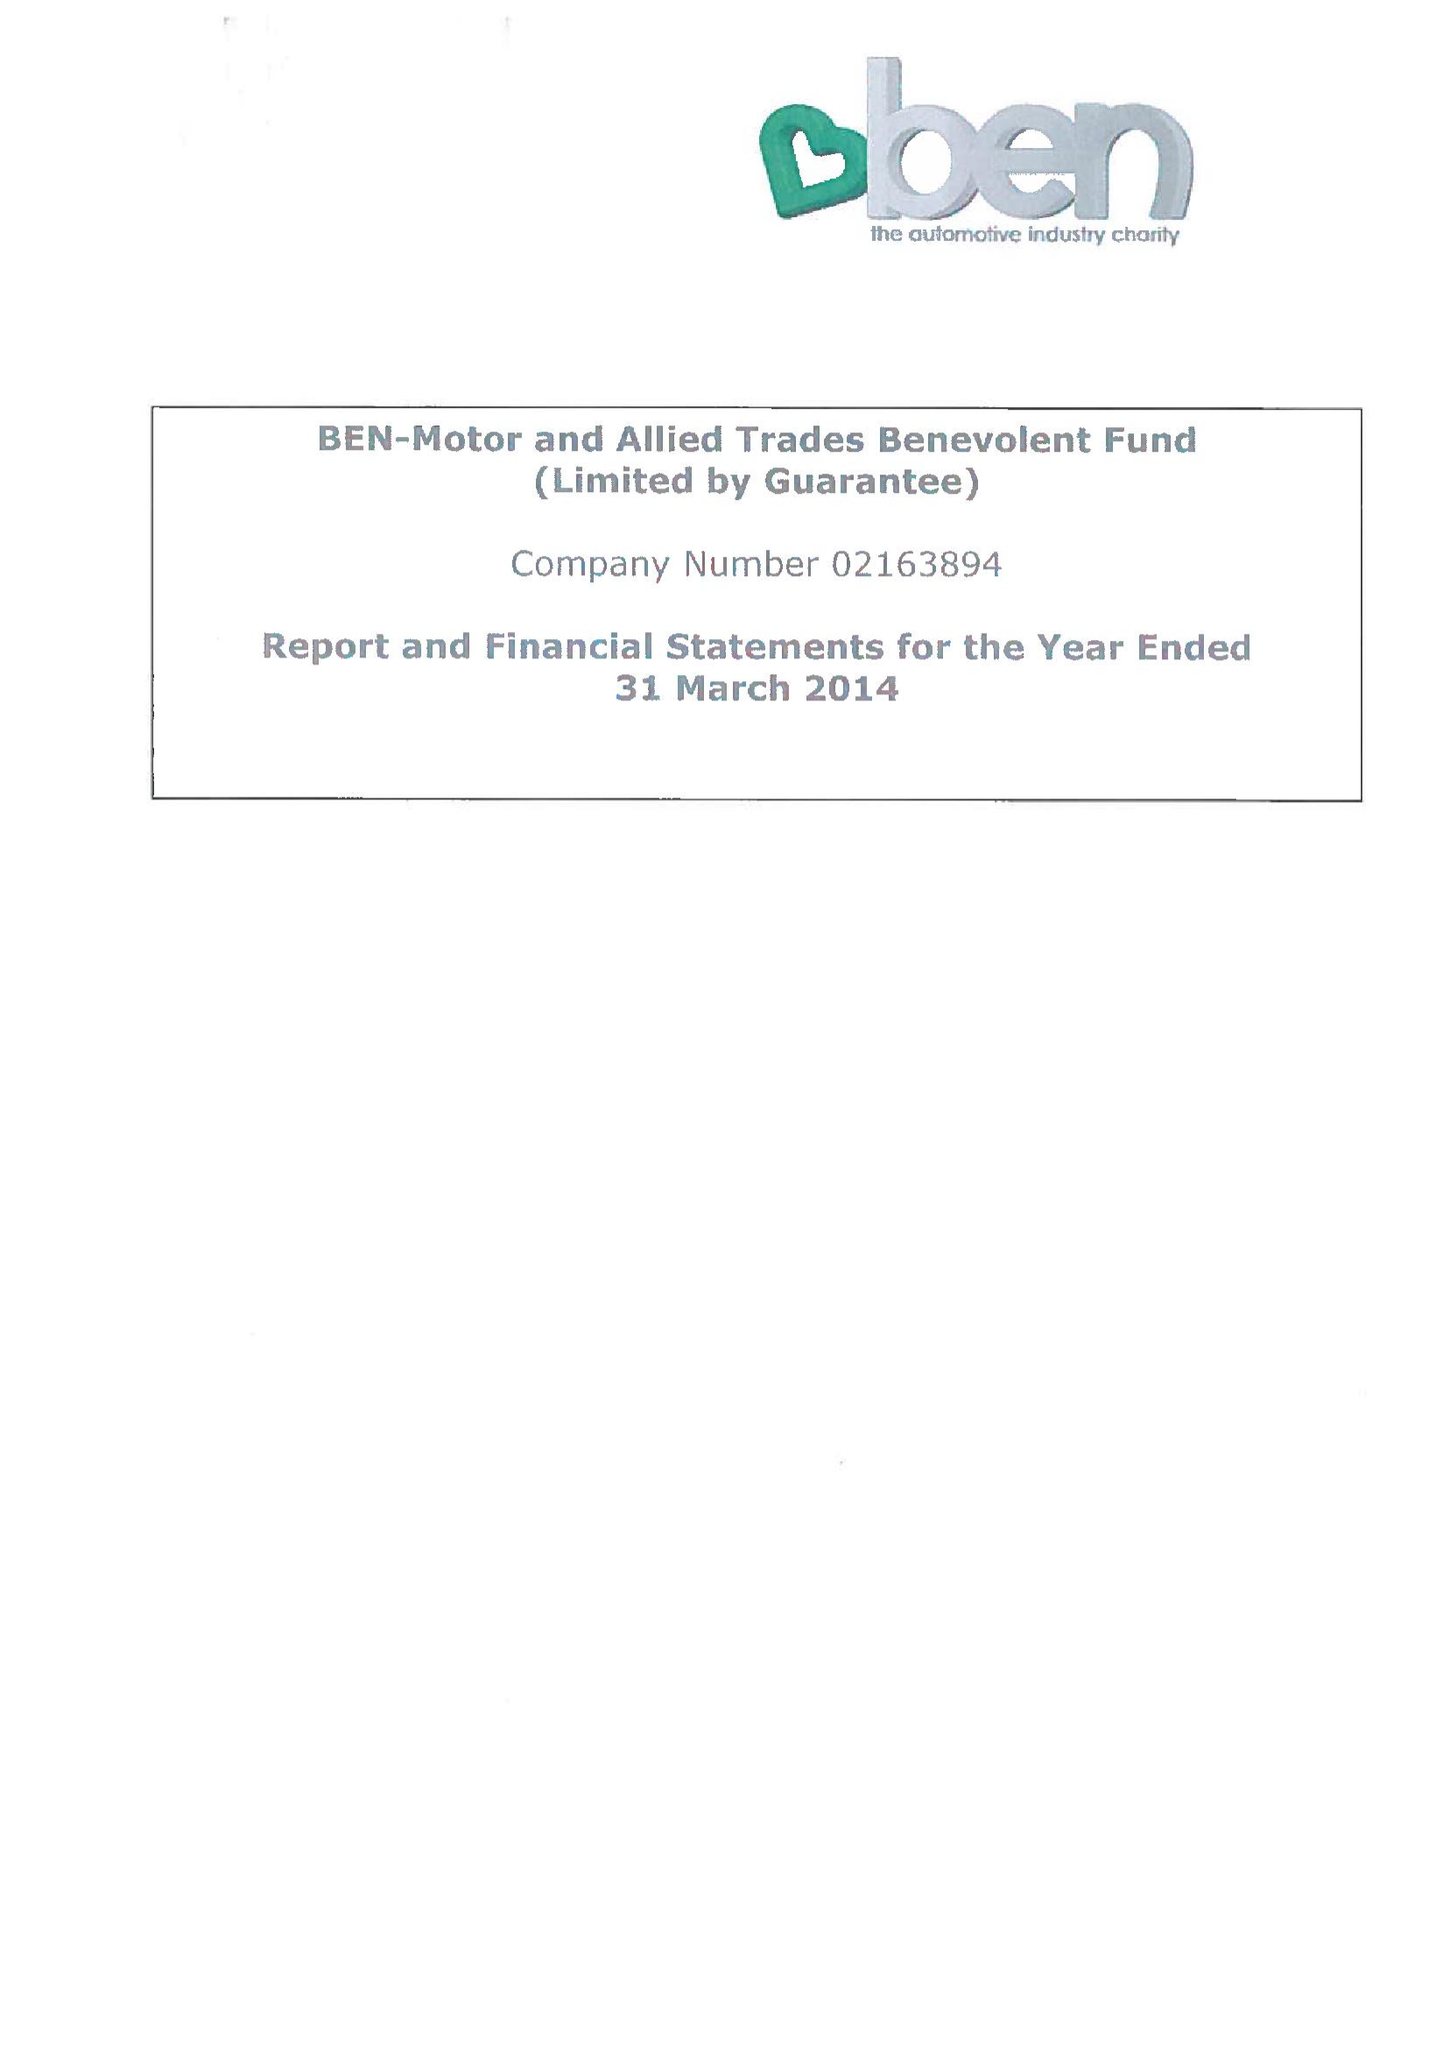What is the value for the address__street_line?
Answer the question using a single word or phrase. RISE ROAD 